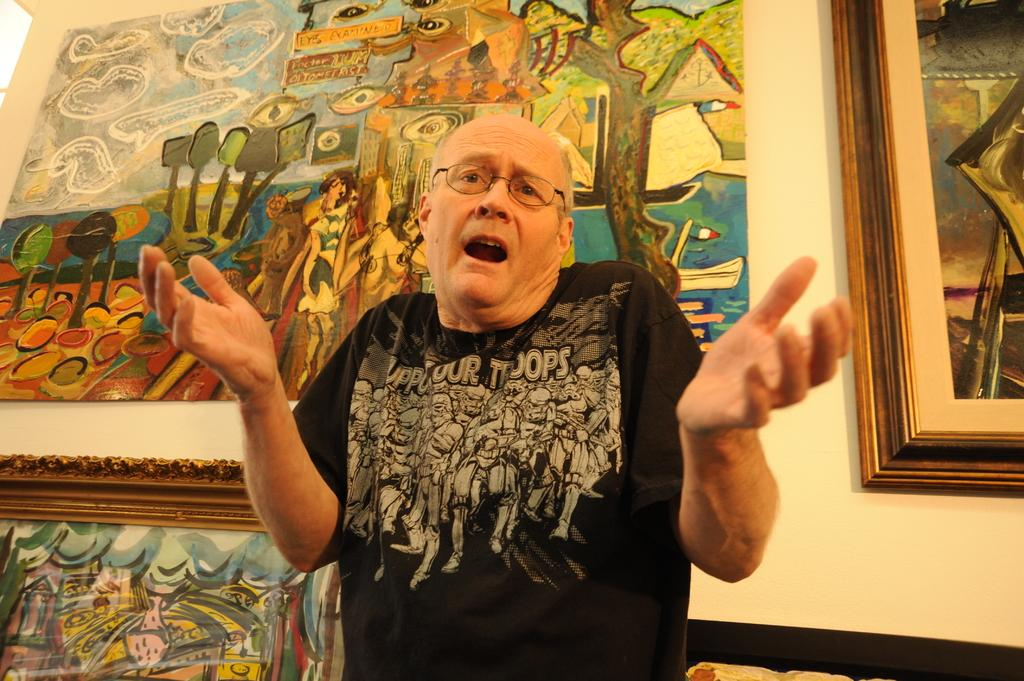Who is present in the image? There is a man in the image. What is the man doing in front of? The man is standing in front of paintings. How is the man expressing himself in the image? The man is expressing something, but the specifics are not clear from the image alone. How many sisters does the man have in the image? There is no information about the man's sisters in the image. What type of potato is being used as a prop in the image? There is no potato present in the image. 